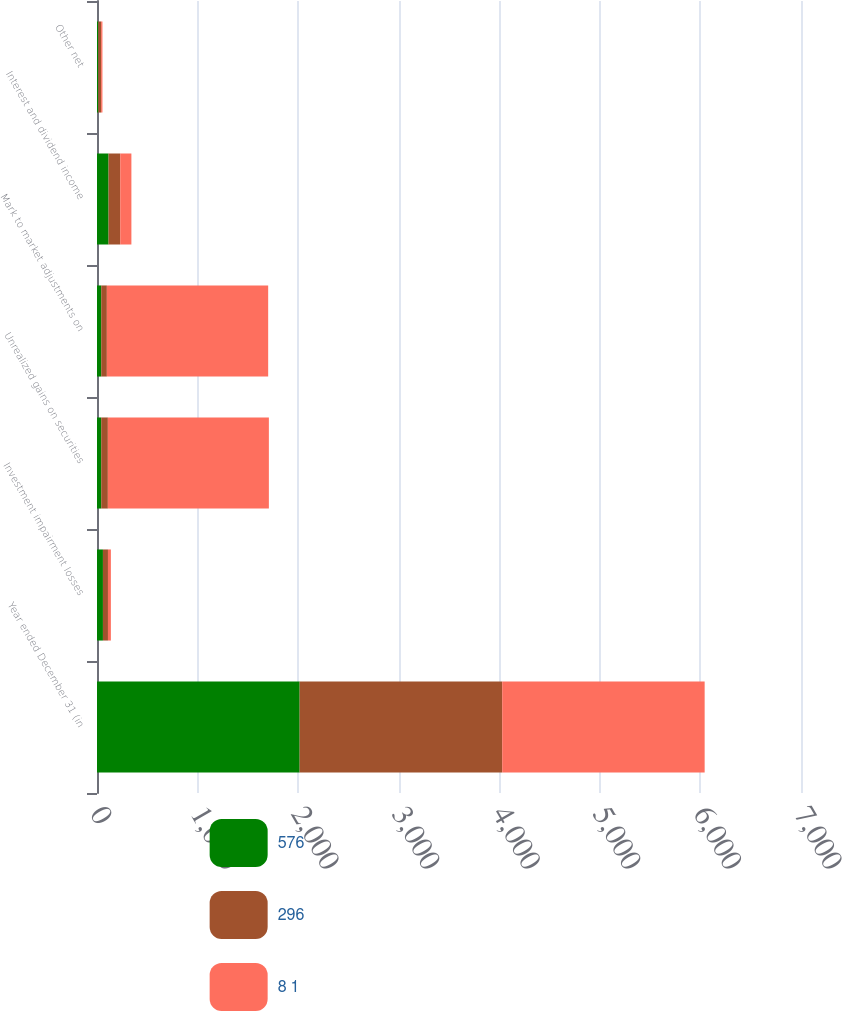<chart> <loc_0><loc_0><loc_500><loc_500><stacked_bar_chart><ecel><fcel>Year ended December 31 (in<fcel>Investment impairment losses<fcel>Unrealized gains on securities<fcel>Mark to market adjustments on<fcel>Interest and dividend income<fcel>Other net<nl><fcel>576<fcel>2015<fcel>59<fcel>42<fcel>42<fcel>115<fcel>13<nl><fcel>296<fcel>2014<fcel>50<fcel>66<fcel>56<fcel>116<fcel>28<nl><fcel>8 1<fcel>2013<fcel>29<fcel>1601<fcel>1604<fcel>111<fcel>13<nl></chart> 